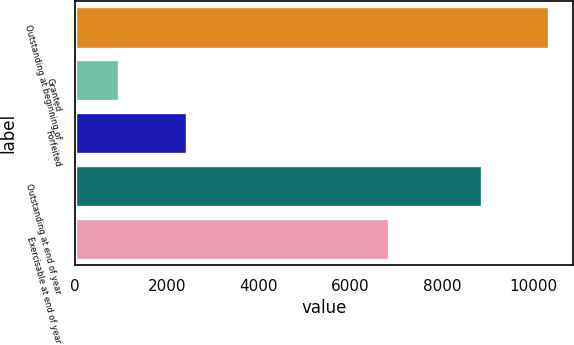Convert chart. <chart><loc_0><loc_0><loc_500><loc_500><bar_chart><fcel>Outstanding at beginning of<fcel>Granted<fcel>Forfeited<fcel>Outstanding at end of year<fcel>Exercisable at end of year<nl><fcel>10344<fcel>965<fcel>2436<fcel>8873<fcel>6840<nl></chart> 